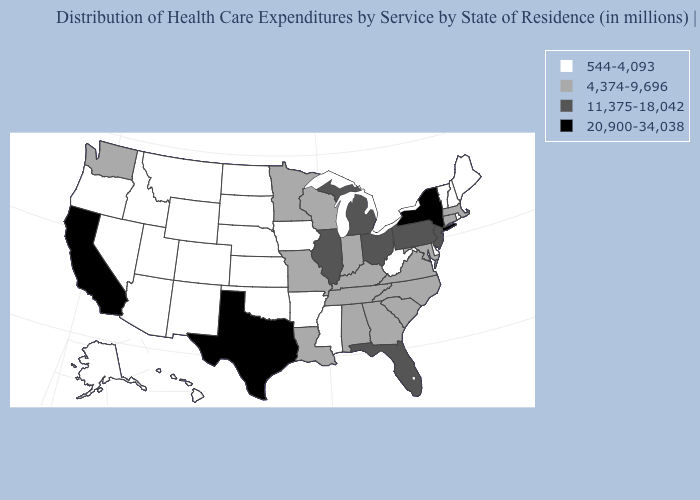Name the states that have a value in the range 4,374-9,696?
Answer briefly. Alabama, Connecticut, Georgia, Indiana, Kentucky, Louisiana, Maryland, Massachusetts, Minnesota, Missouri, North Carolina, South Carolina, Tennessee, Virginia, Washington, Wisconsin. Does Texas have the highest value in the USA?
Keep it brief. Yes. Does the first symbol in the legend represent the smallest category?
Give a very brief answer. Yes. Among the states that border Colorado , which have the lowest value?
Answer briefly. Arizona, Kansas, Nebraska, New Mexico, Oklahoma, Utah, Wyoming. Does the map have missing data?
Be succinct. No. What is the value of Maryland?
Short answer required. 4,374-9,696. What is the value of Arkansas?
Quick response, please. 544-4,093. Name the states that have a value in the range 20,900-34,038?
Short answer required. California, New York, Texas. Does Nevada have the same value as Oregon?
Short answer required. Yes. Does Arkansas have the lowest value in the South?
Keep it brief. Yes. Among the states that border Arkansas , which have the highest value?
Be succinct. Texas. Name the states that have a value in the range 20,900-34,038?
Give a very brief answer. California, New York, Texas. What is the lowest value in states that border New Hampshire?
Concise answer only. 544-4,093. Name the states that have a value in the range 20,900-34,038?
Short answer required. California, New York, Texas. Name the states that have a value in the range 20,900-34,038?
Quick response, please. California, New York, Texas. 